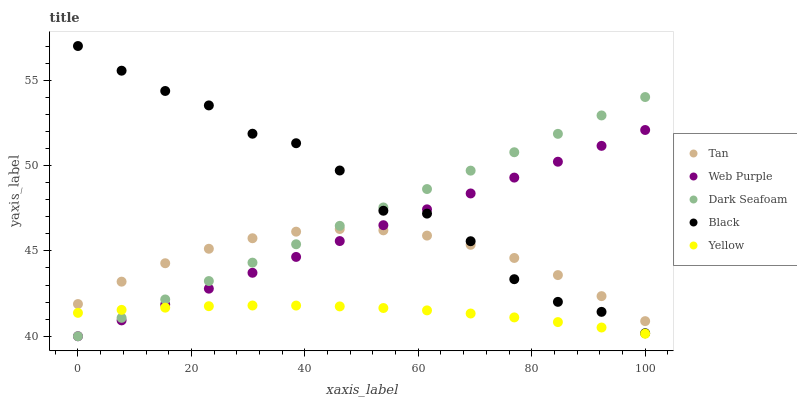Does Yellow have the minimum area under the curve?
Answer yes or no. Yes. Does Black have the maximum area under the curve?
Answer yes or no. Yes. Does Black have the minimum area under the curve?
Answer yes or no. No. Does Yellow have the maximum area under the curve?
Answer yes or no. No. Is Dark Seafoam the smoothest?
Answer yes or no. Yes. Is Black the roughest?
Answer yes or no. Yes. Is Yellow the smoothest?
Answer yes or no. No. Is Yellow the roughest?
Answer yes or no. No. Does Web Purple have the lowest value?
Answer yes or no. Yes. Does Yellow have the lowest value?
Answer yes or no. No. Does Black have the highest value?
Answer yes or no. Yes. Does Yellow have the highest value?
Answer yes or no. No. Is Yellow less than Black?
Answer yes or no. Yes. Is Tan greater than Yellow?
Answer yes or no. Yes. Does Dark Seafoam intersect Web Purple?
Answer yes or no. Yes. Is Dark Seafoam less than Web Purple?
Answer yes or no. No. Is Dark Seafoam greater than Web Purple?
Answer yes or no. No. Does Yellow intersect Black?
Answer yes or no. No. 